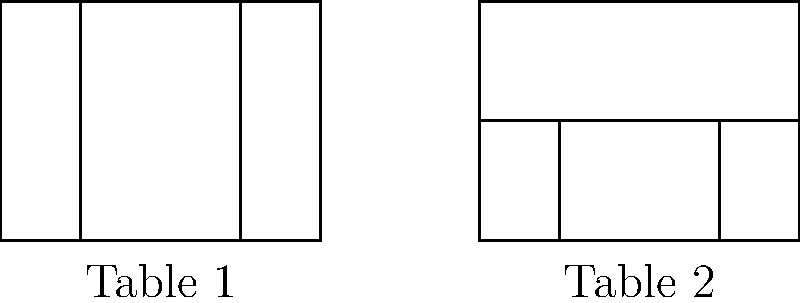Two custom wooden tables are being considered for a dining room. Table 1 has four legs, one at each corner, while Table 2 has a central support beam with two legs. Both tables have the same rectangular top measuring 4 units by 3 units. Are these two table designs congruent? To determine if the two table designs are congruent, we need to consider the following steps:

1. Definition of congruence: Two geometric figures are congruent if they have the same shape and size, meaning that one figure can be transformed into the other through a combination of rigid transformations (translations, rotations, and reflections).

2. Comparing the table tops:
   - Both tables have rectangular tops with the same dimensions (4 units by 3 units).
   - The table tops are congruent to each other.

3. Comparing the support structures:
   - Table 1 has four legs, one at each corner.
   - Table 2 has a central support beam with two legs.
   - The support structures are different and cannot be transformed into each other through rigid transformations.

4. Overall comparison:
   - While the table tops are congruent, the support structures are fundamentally different.
   - The overall shapes of the tables are not the same due to the different leg arrangements.
   - There is no combination of rigid transformations that can turn one table design into the other.

5. Conclusion:
   - Since the entire structures of the tables cannot be transformed into each other through rigid transformations, they are not congruent.
Answer: Not congruent 